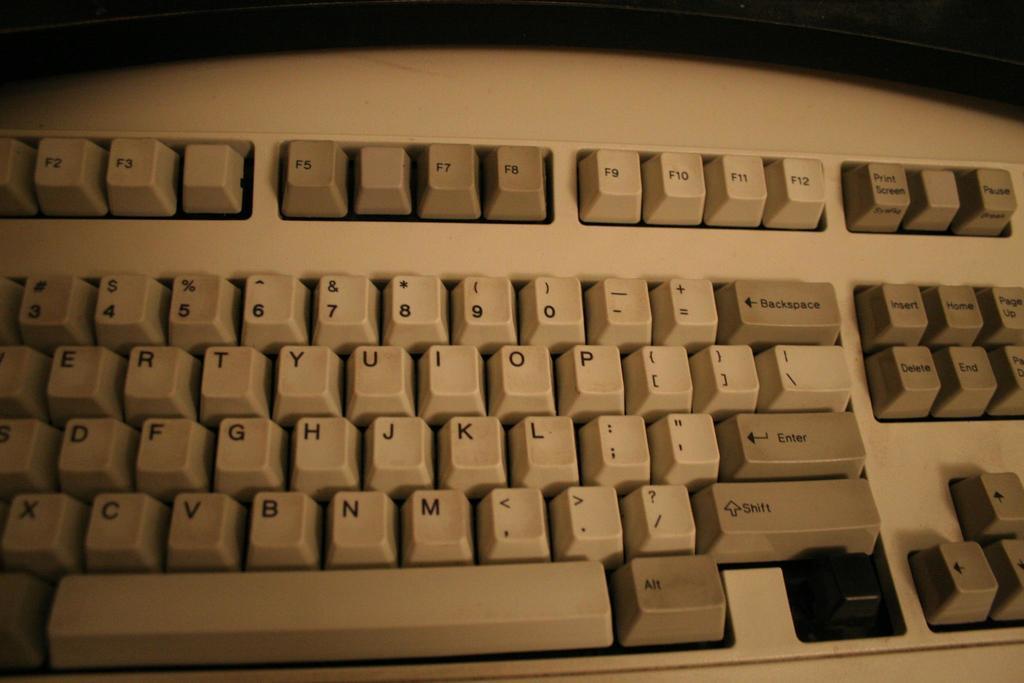What are the top row of keys?
Keep it short and to the point. Function keys. What is the last number on the right?
Provide a short and direct response. 0. 